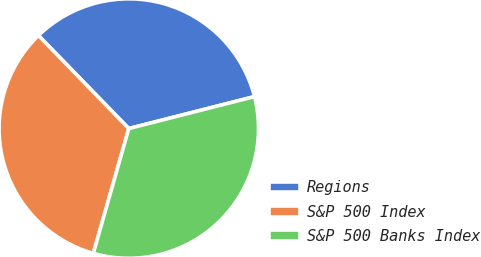Convert chart to OTSL. <chart><loc_0><loc_0><loc_500><loc_500><pie_chart><fcel>Regions<fcel>S&P 500 Index<fcel>S&P 500 Banks Index<nl><fcel>33.3%<fcel>33.33%<fcel>33.37%<nl></chart> 